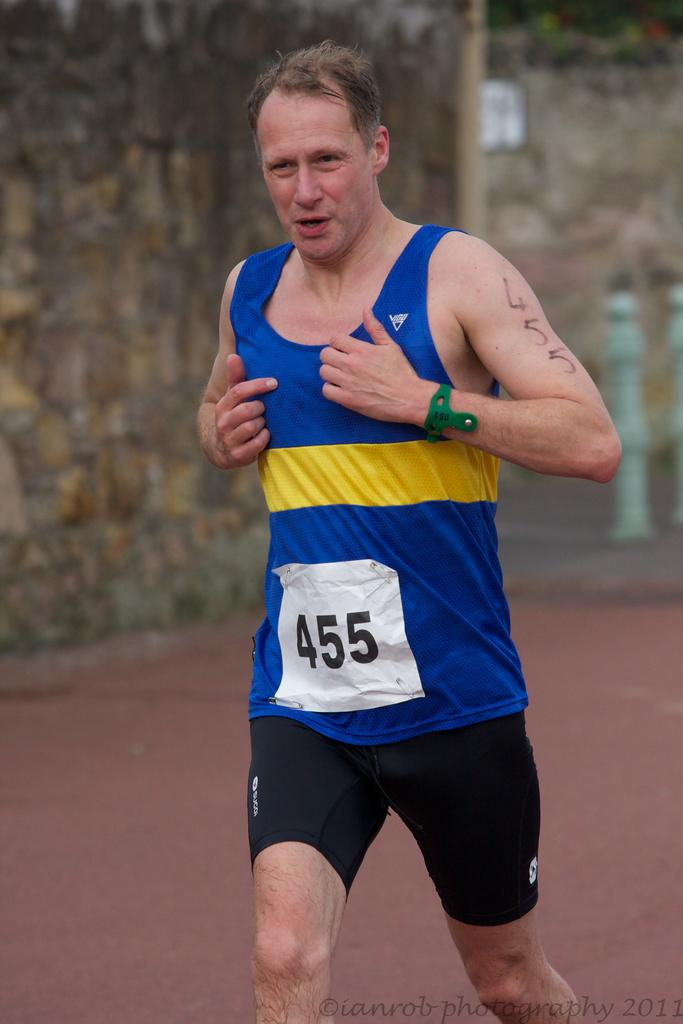What is the main subject of the image? The main subject of the image is a man. What is the man doing in the image? The man is running in the image. What color is the t-shirt the man is wearing? The man is wearing a blue t-shirt. Is there any text on the man's t-shirt? Yes, there is text written on the man's t-shirt. What can be seen in the background of the image? There is a wall in the background of the image. What type of prose is the man reading while running in the image? There is no prose visible in the image, as the man is running and not reading anything. What are the man's hobbies, as depicted in the image? The image only shows the man running, so it is not possible to determine his hobbies from the image alone. 